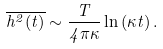<formula> <loc_0><loc_0><loc_500><loc_500>\overline { h ^ { 2 } ( t ) } \sim \frac { T } { 4 \pi \kappa } \ln \left ( \kappa t \right ) .</formula> 